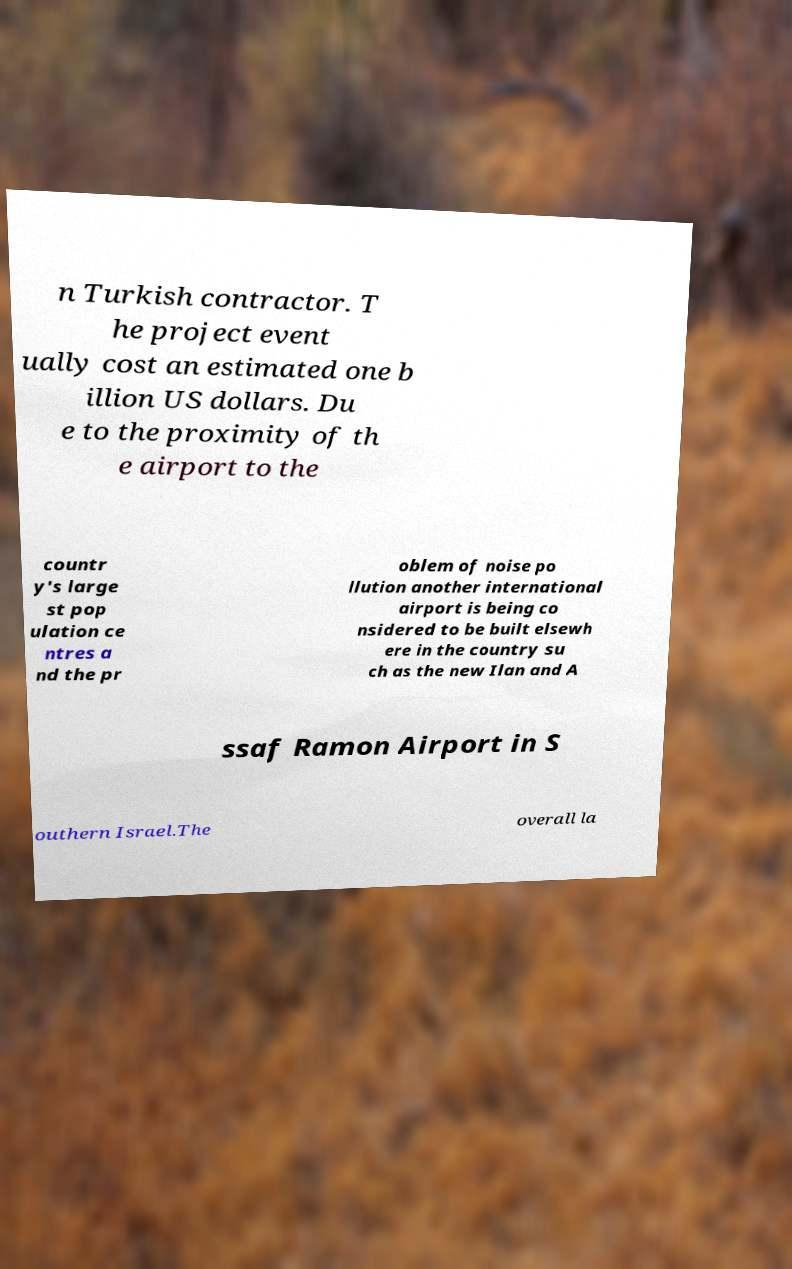Could you extract and type out the text from this image? n Turkish contractor. T he project event ually cost an estimated one b illion US dollars. Du e to the proximity of th e airport to the countr y's large st pop ulation ce ntres a nd the pr oblem of noise po llution another international airport is being co nsidered to be built elsewh ere in the country su ch as the new Ilan and A ssaf Ramon Airport in S outhern Israel.The overall la 